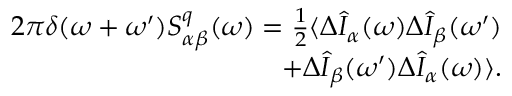Convert formula to latex. <formula><loc_0><loc_0><loc_500><loc_500>\begin{array} { r } { 2 \pi \delta ( \omega + \omega ^ { \prime } ) S _ { \alpha \beta } ^ { q } ( \omega ) = \frac { 1 } { 2 } \langle \Delta \hat { I } _ { \alpha } ( \omega ) \Delta \hat { I } _ { \beta } ( \omega ^ { \prime } ) } \\ { + \Delta \hat { I } _ { \beta } ( \omega ^ { \prime } ) \Delta \hat { I } _ { \alpha } ( \omega ) \rangle . } \end{array}</formula> 